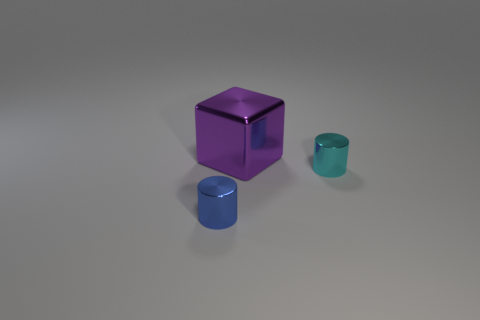Add 3 tiny red shiny cylinders. How many objects exist? 6 Subtract all blue cylinders. How many cylinders are left? 1 Subtract 1 blocks. How many blocks are left? 0 Add 1 purple blocks. How many purple blocks are left? 2 Add 2 large red metallic blocks. How many large red metallic blocks exist? 2 Subtract 0 blue spheres. How many objects are left? 3 Subtract all cylinders. How many objects are left? 1 Subtract all blue cubes. Subtract all purple spheres. How many cubes are left? 1 Subtract all large purple metallic cubes. Subtract all big metallic things. How many objects are left? 1 